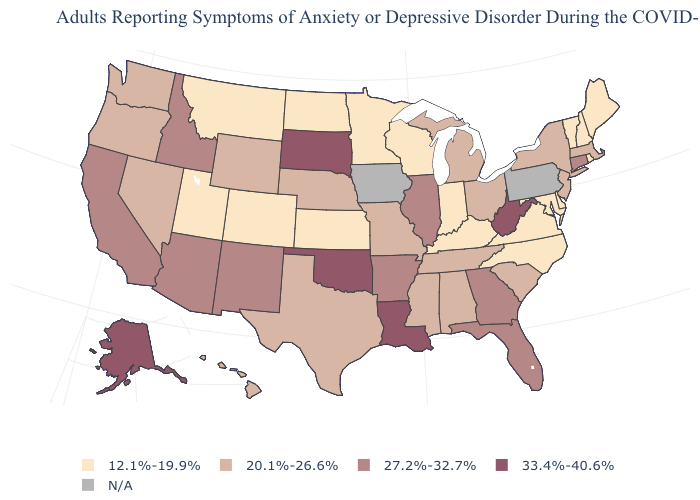How many symbols are there in the legend?
Give a very brief answer. 5. What is the value of Alabama?
Concise answer only. 20.1%-26.6%. What is the value of New York?
Be succinct. 20.1%-26.6%. What is the value of New Hampshire?
Write a very short answer. 12.1%-19.9%. What is the highest value in the USA?
Short answer required. 33.4%-40.6%. What is the lowest value in the West?
Concise answer only. 12.1%-19.9%. What is the highest value in the USA?
Short answer required. 33.4%-40.6%. What is the value of South Dakota?
Concise answer only. 33.4%-40.6%. Which states have the lowest value in the West?
Keep it brief. Colorado, Montana, Utah. Is the legend a continuous bar?
Short answer required. No. What is the value of Oregon?
Be succinct. 20.1%-26.6%. What is the value of North Carolina?
Write a very short answer. 12.1%-19.9%. Is the legend a continuous bar?
Write a very short answer. No. Does Oklahoma have the highest value in the South?
Give a very brief answer. Yes. 